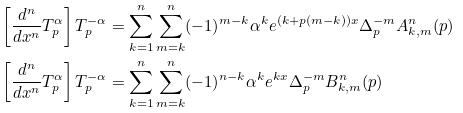<formula> <loc_0><loc_0><loc_500><loc_500>& \left [ \frac { d ^ { n } } { d x ^ { n } } T _ { p } ^ { \alpha } \right ] T _ { p } ^ { - \alpha } = \sum _ { k = 1 } ^ { n } \sum _ { m = k } ^ { n } ( - 1 ) ^ { m - k } \alpha ^ { k } e ^ { ( k + p ( m - k ) ) x } \Delta _ { p } ^ { - m } A _ { k , m } ^ { n } ( p ) \\ & \left [ \frac { d ^ { n } } { d x ^ { n } } T _ { p } ^ { \alpha } \right ] T _ { p } ^ { - \alpha } = \sum _ { k = 1 } ^ { n } \sum _ { m = k } ^ { n } ( - 1 ) ^ { n - k } \alpha ^ { k } e ^ { k x } \Delta _ { p } ^ { - m } B _ { k , m } ^ { n } ( p )</formula> 